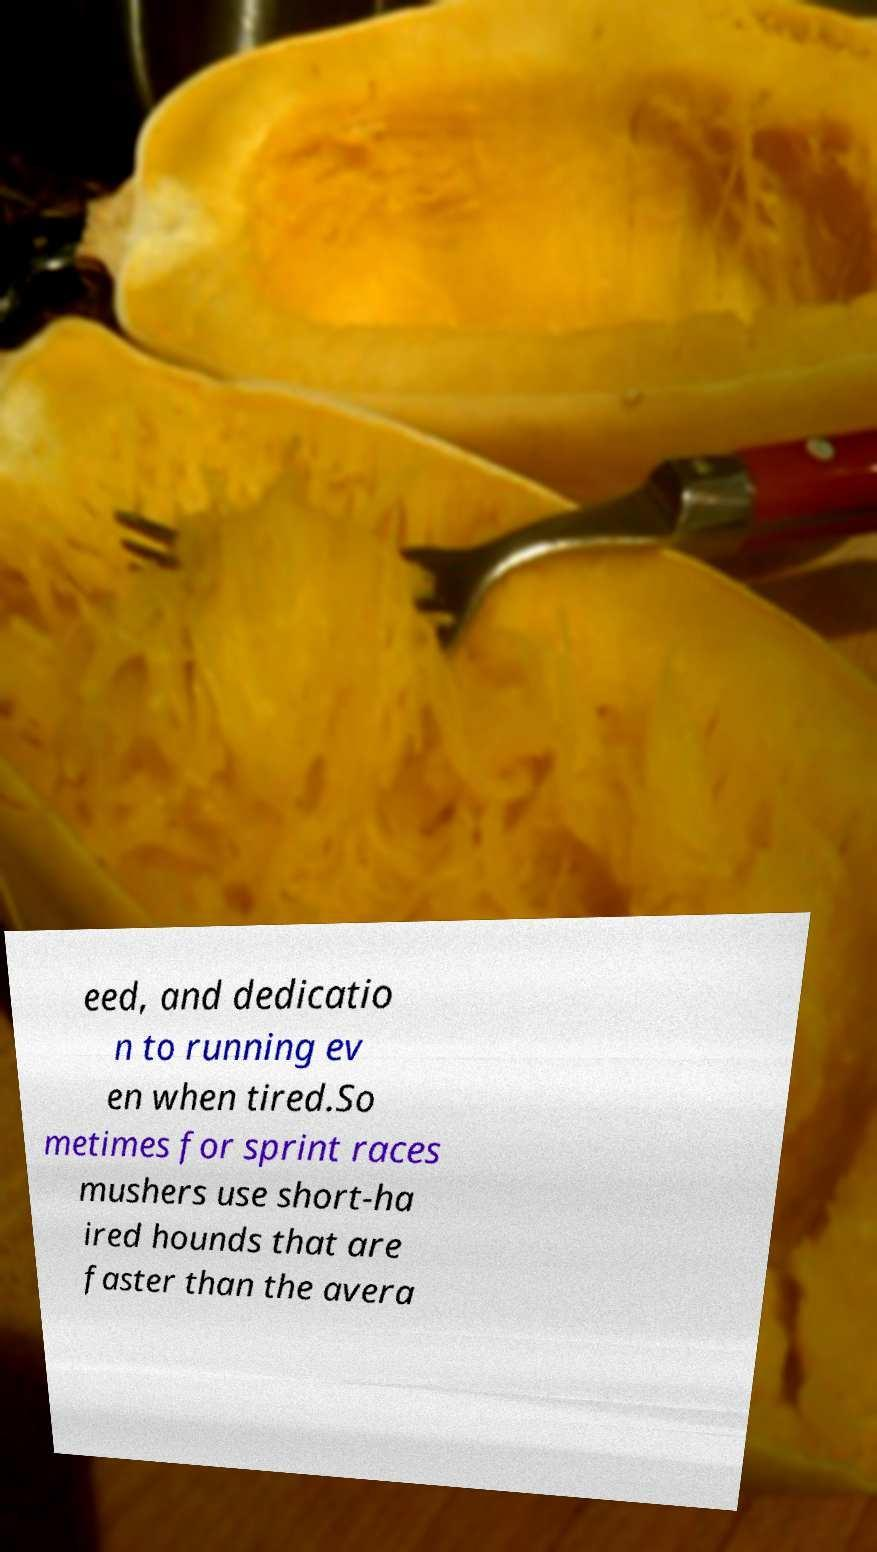Please identify and transcribe the text found in this image. eed, and dedicatio n to running ev en when tired.So metimes for sprint races mushers use short-ha ired hounds that are faster than the avera 